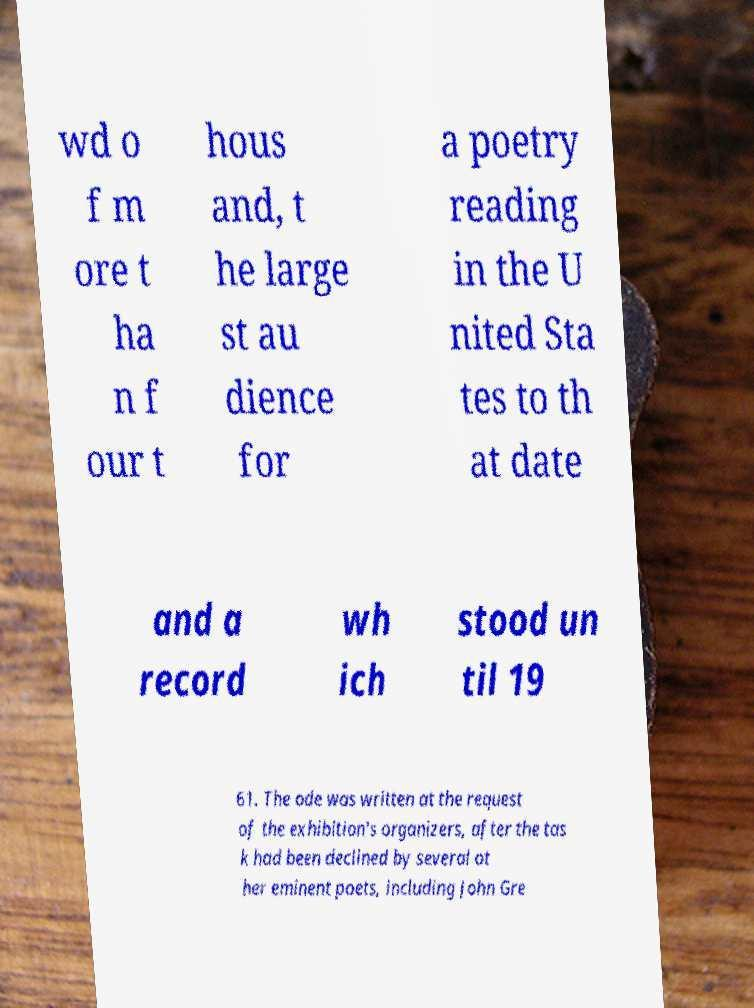Can you accurately transcribe the text from the provided image for me? wd o f m ore t ha n f our t hous and, t he large st au dience for a poetry reading in the U nited Sta tes to th at date and a record wh ich stood un til 19 61. The ode was written at the request of the exhibition's organizers, after the tas k had been declined by several ot her eminent poets, including John Gre 